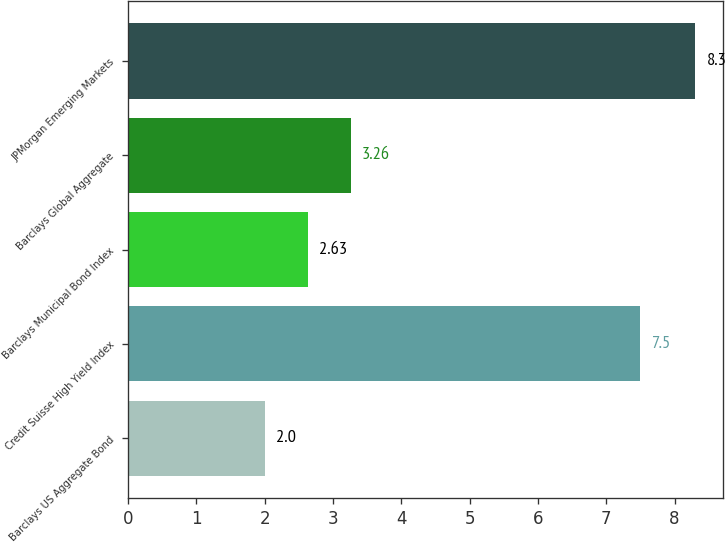Convert chart. <chart><loc_0><loc_0><loc_500><loc_500><bar_chart><fcel>Barclays US Aggregate Bond<fcel>Credit Suisse High Yield Index<fcel>Barclays Municipal Bond Index<fcel>Barclays Global Aggregate<fcel>JPMorgan Emerging Markets<nl><fcel>2<fcel>7.5<fcel>2.63<fcel>3.26<fcel>8.3<nl></chart> 